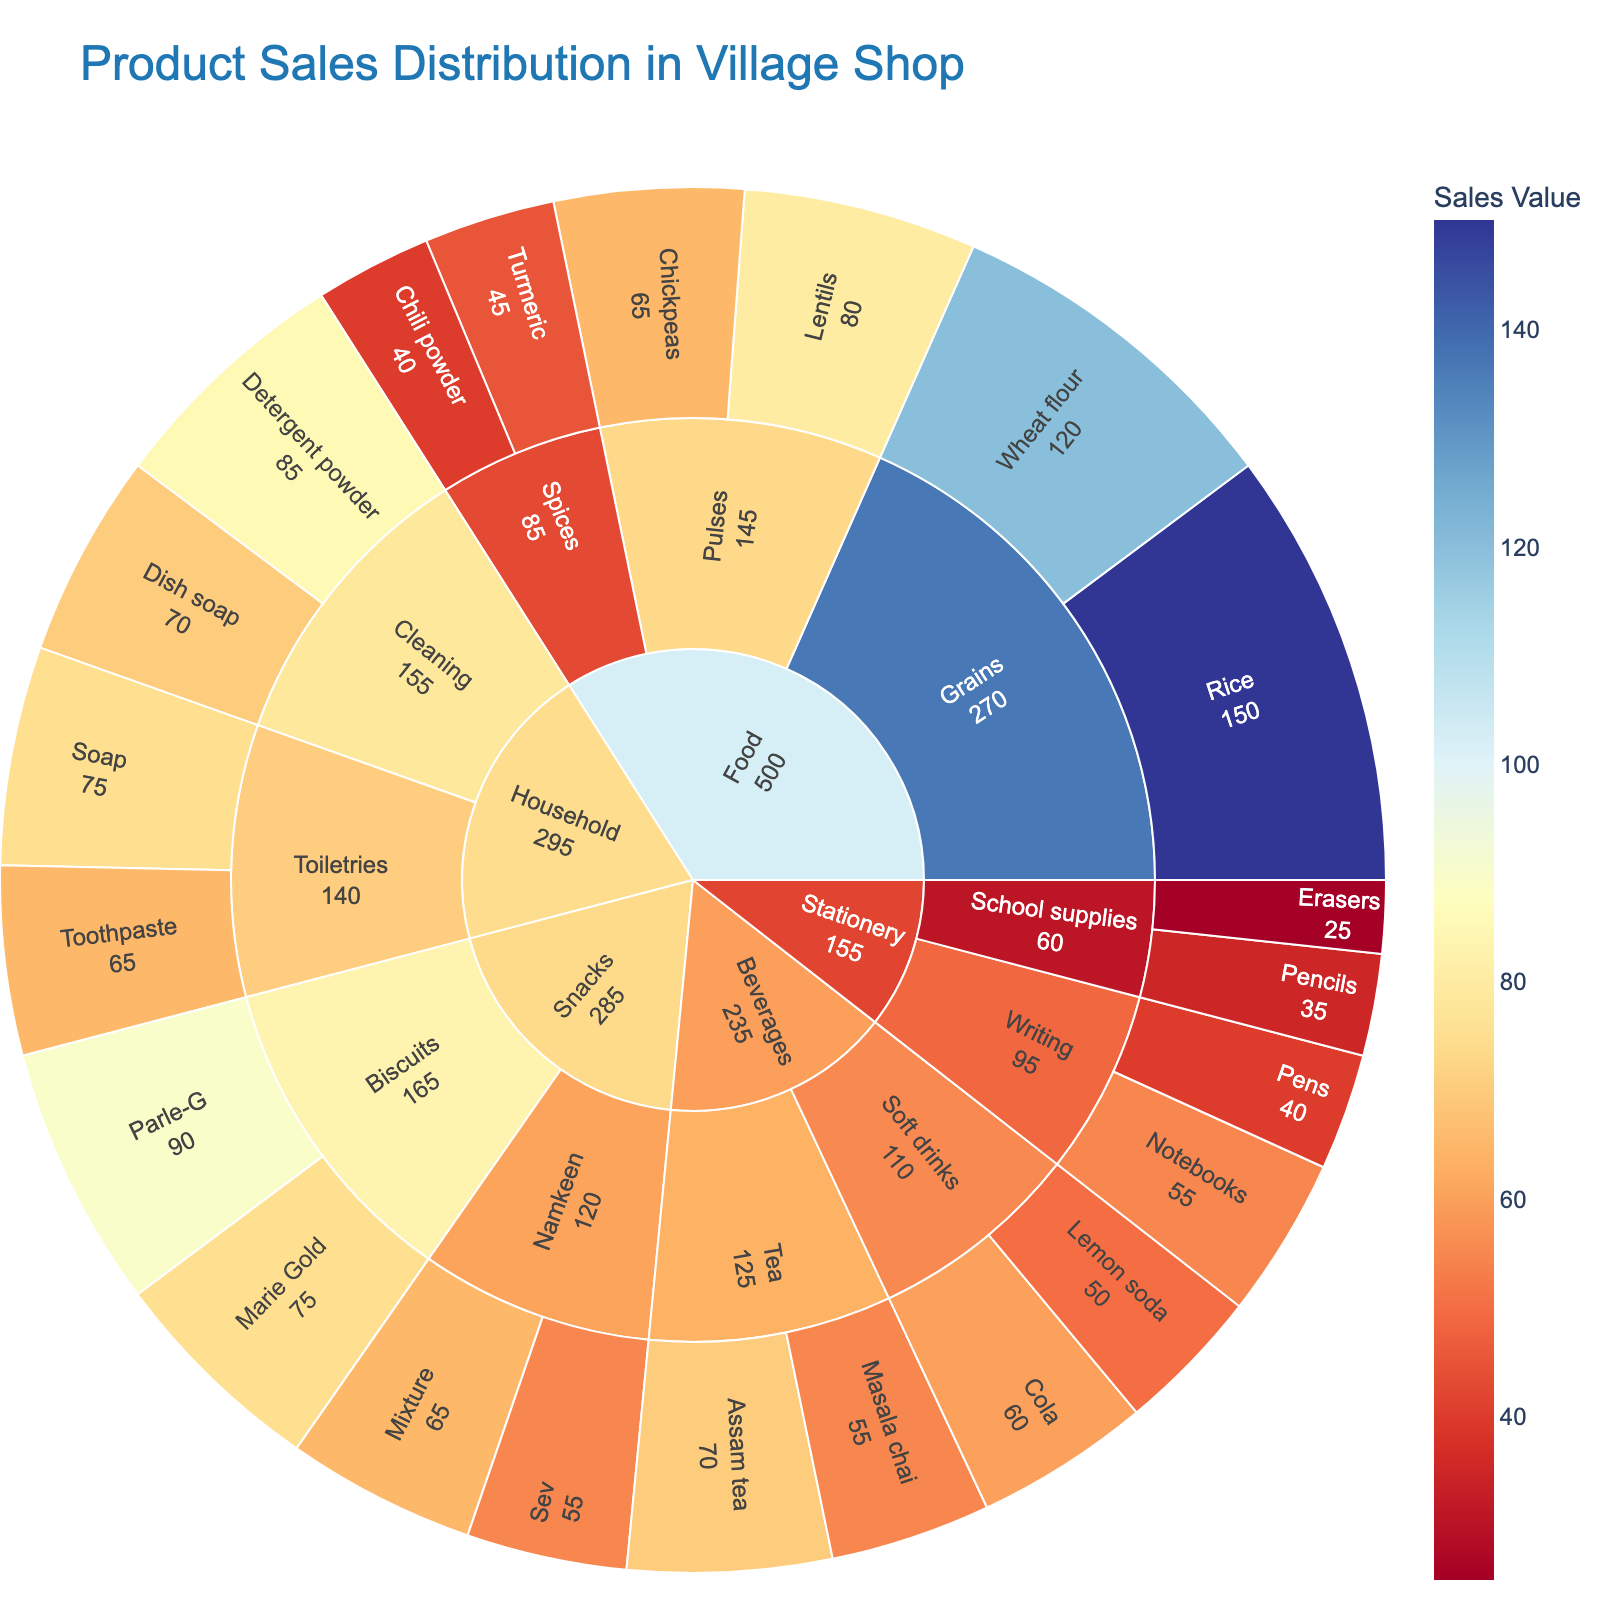Which product has the highest sales in the Snacks category? Locate the Snacks category within the plot and examine its subcategories (Biscuits and Namkeen). Check the sales values for each product under these subcategories. Parle-G has the highest sales value of 90.
Answer: Parle-G What is the total sales value of the Food category? Add up the sales values of all products under the Food category. This includes Rice (150), Wheat flour (120), Lentils (80), Chickpeas (65), Turmeric (45), and Chili powder (40). The total is 150 + 120 + 80 + 65 + 45 + 40 = 500.
Answer: 500 Which subcategory in the Household category has the higher total sales value? Compare the total sales values of the subcategories Cleaning and Toiletries under the Household category. Cleaning has products with sales values of Detergent powder (85) and Dish soap (70), totaling 85 + 70 = 155. Toiletries has Toothpaste (65) and Soap (75), totaling 65 + 75 = 140. Hence, Cleaning has higher total sales.
Answer: Cleaning Which category has the least total sales value? Compare the total sales values of all main categories: Food, Beverages, Household, Stationery, and Snacks. Stationery has the combined sales values of Pens (40), Notebooks (55), Pencils (35), and Erasers (25), totaling 40 + 55 + 35 + 25 = 155. Since this is the least among the main categories, the answer is Stationery.
Answer: Stationery How much more is the sales value of Rice compared to Soap? Find the sales values of Rice and Soap from the plot, which are 150 and 75, respectively. Calculate the difference: 150 - 75 = 75.
Answer: 75 What is the average sales value of products in the Beverages category? In the Beverages category, the sales values are Assam tea (70), Masala chai (55), Cola (60), and Lemon soda (50). The sum of these values is 70 + 55 + 60 + 50 = 235. The average is 235 divided by the number of products, which is 4: 235/4 = 58.75.
Answer: 58.75 Which has higher sales — the highest-selling product in Beverages or the lowest-selling product in Food? The highest-selling product in Beverages is Assam tea with a sales value of 70. The lowest-selling product in Food appears to be Chili powder with a sales value of 40. Since 70 is greater than 40, the highest-selling product in Beverages has higher sales.
Answer: Highest-selling product in Beverages What’s the combined sales value of the Soft drinks subcategory within the Beverages category? Locate the Beverages category and identify the Soft drinks subcategory. Sum the values for Cola (60) and Lemon soda (50): 60 + 50 = 110.
Answer: 110 